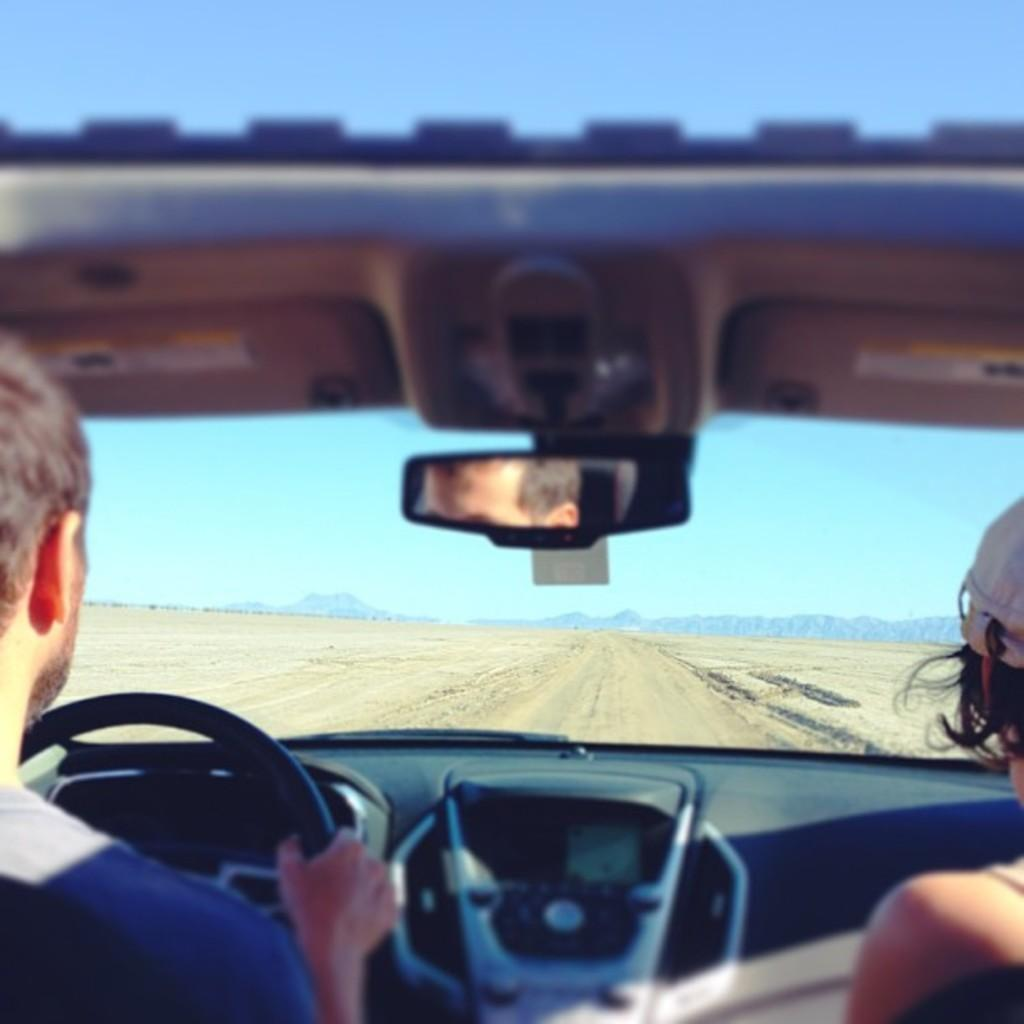Who is driving the car in the image? There is a man driving the car in the image. Who is also present in the car? There is a woman sitting in the car. What can be seen in the background of the image? The car is on a road with hills in the background. How would you describe the weather based on the image? The sky is sunny in the image. What type of oven is visible in the image? There is no oven present in the image. How many minutes does the minute hand move in the image? There is no clock or timepiece present in the image, so it is not possible to determine how many minutes the minute hand moves. 